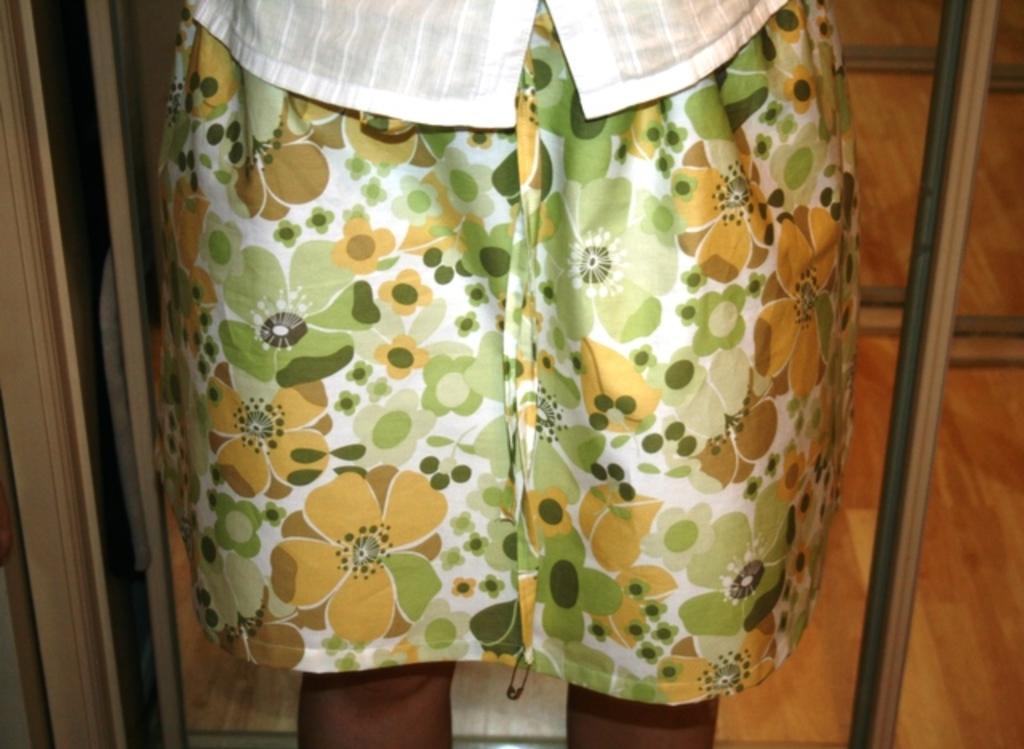How would you summarize this image in a sentence or two? In this picture we can see a person in the front, at the bottom there is a wooden floor. 